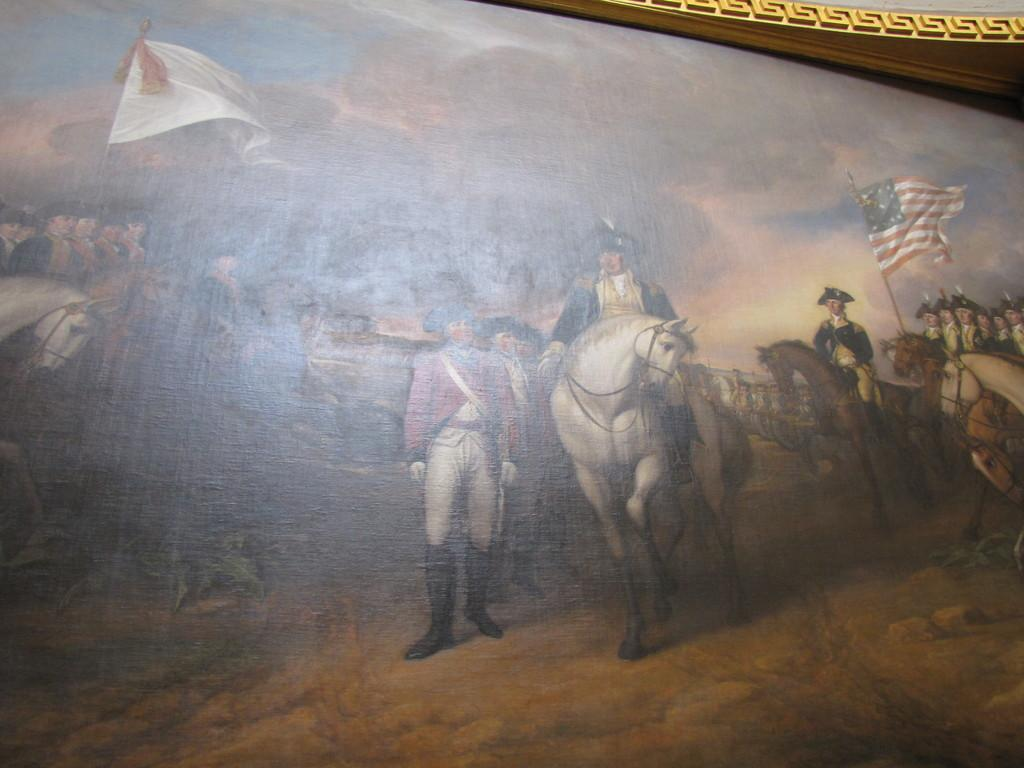What is the main subject of the painting in the image? The painting depicts horses and people. What are the people in the painting doing? Some people in the painting are sitting on horses. What can be seen in the background of the painting? The sky is visible in the image. What type of notebook is being used by the horses in the painting? There is no notebook present in the painting; it depicts horses and people. What place is the painting set in? The painting does not depict a specific place, as it focuses on the horses and people. 